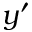<formula> <loc_0><loc_0><loc_500><loc_500>y ^ { \prime }</formula> 